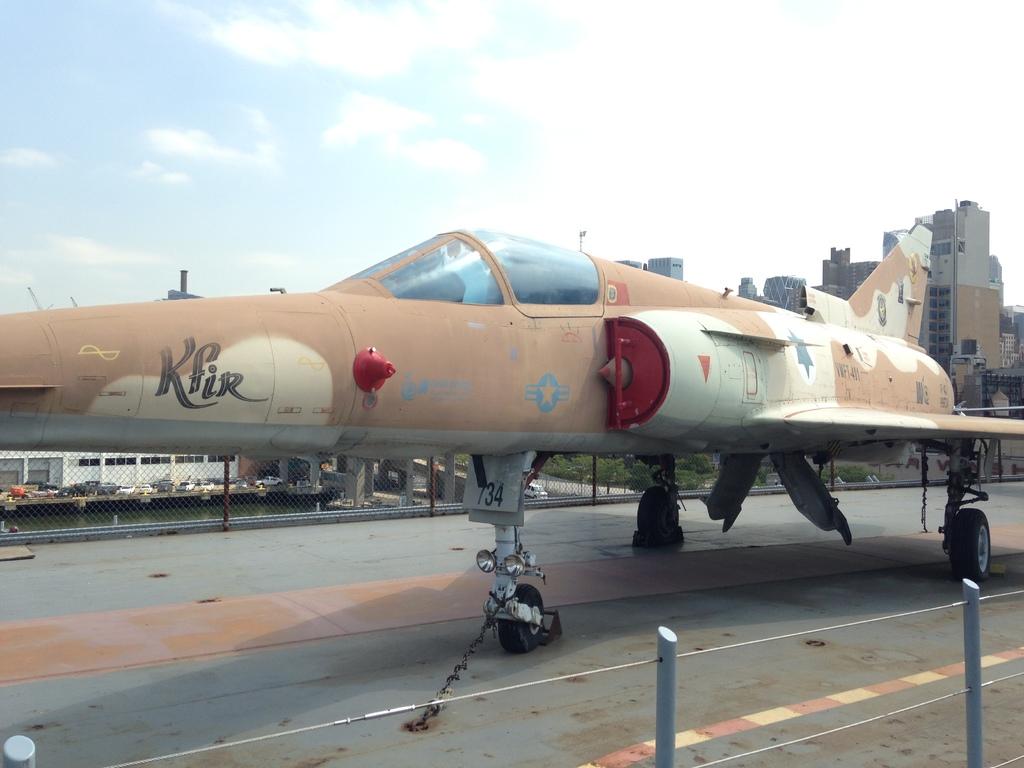What does the graffiti on the plane say?
Ensure brevity in your answer.  Kfir. What number is written just above the plane's front wheel?
Keep it short and to the point. 734. 